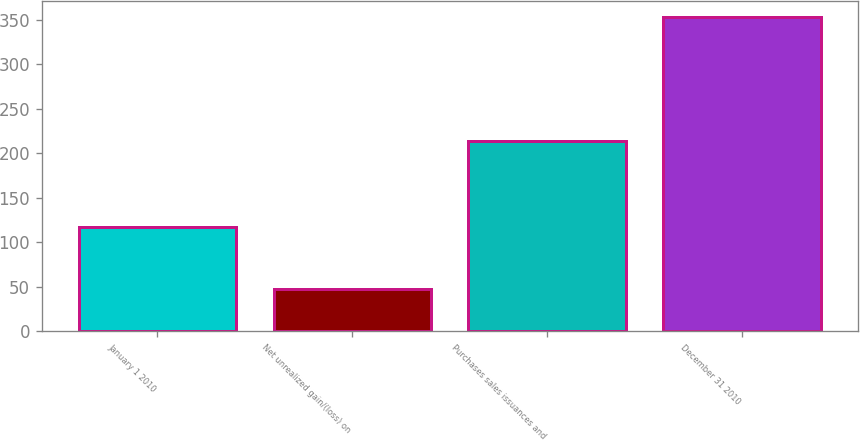<chart> <loc_0><loc_0><loc_500><loc_500><bar_chart><fcel>January 1 2010<fcel>Net unrealized gain/(loss) on<fcel>Purchases sales issuances and<fcel>December 31 2010<nl><fcel>117<fcel>48<fcel>214<fcel>353<nl></chart> 